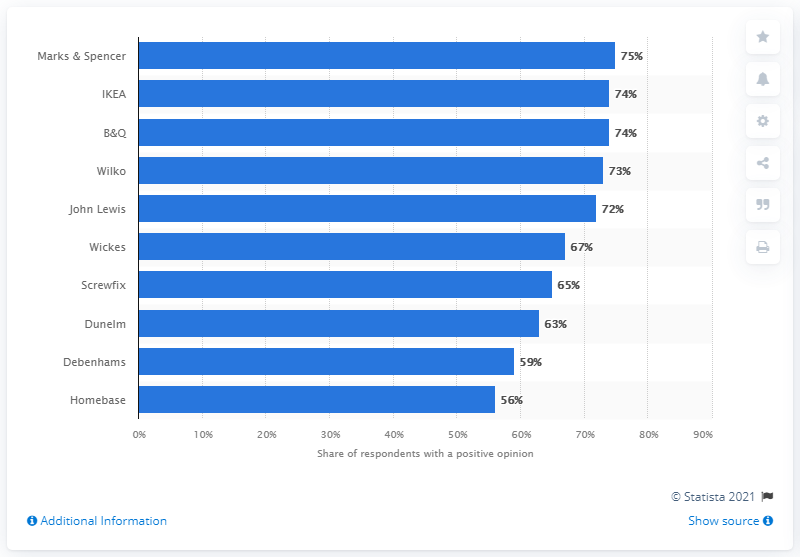Give some essential details in this illustration. B&Q was the second most popular department store in the United Kingdom. 